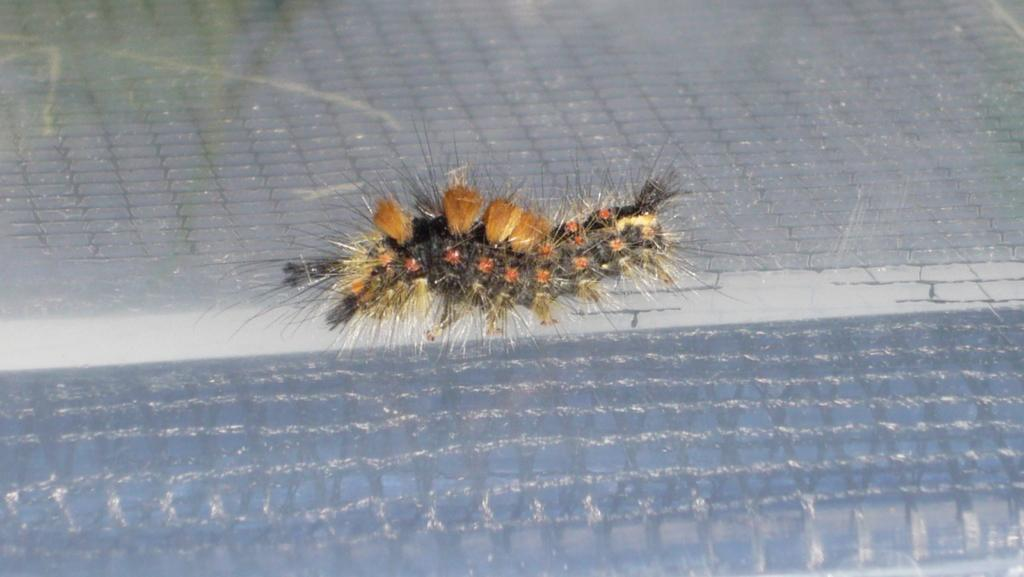What type of creature can be seen in the image? There is an insect in the image. What is the primary setting of the image? The background of the image appears to be a floor. How many clocks are visible in the image? There are no clocks present in the image; it features an insect and a floor. What type of amusement can be seen in the image? There is no amusement present in the image; it features an insect and a floor. 